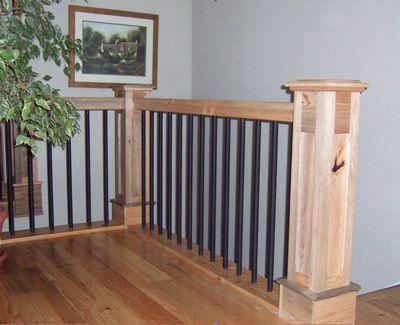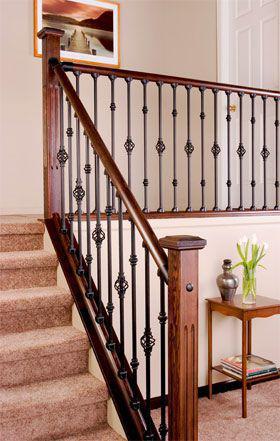The first image is the image on the left, the second image is the image on the right. For the images displayed, is the sentence "The left image features corner posts with square cap tops and straight black vertical bars with no embellishments." factually correct? Answer yes or no. Yes. The first image is the image on the left, the second image is the image on the right. Assess this claim about the two images: "The left image shows the inside of a corner of a railing.". Correct or not? Answer yes or no. Yes. 